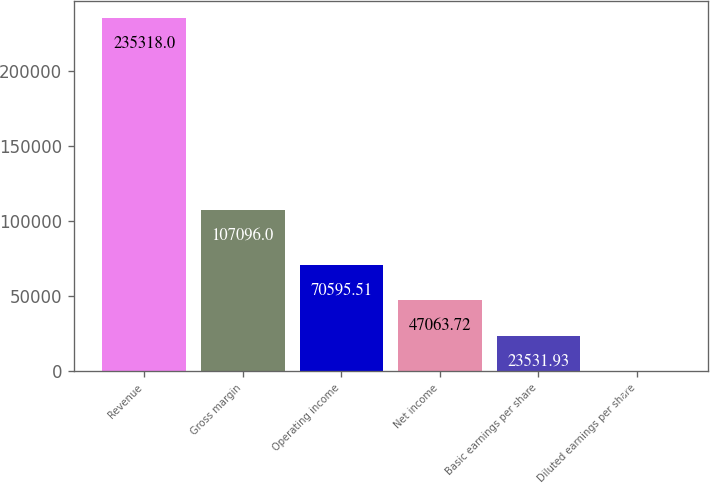<chart> <loc_0><loc_0><loc_500><loc_500><bar_chart><fcel>Revenue<fcel>Gross margin<fcel>Operating income<fcel>Net income<fcel>Basic earnings per share<fcel>Diluted earnings per share<nl><fcel>235318<fcel>107096<fcel>70595.5<fcel>47063.7<fcel>23531.9<fcel>0.14<nl></chart> 